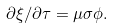Convert formula to latex. <formula><loc_0><loc_0><loc_500><loc_500>\partial \xi / \partial \tau = \mu \sigma \phi .</formula> 